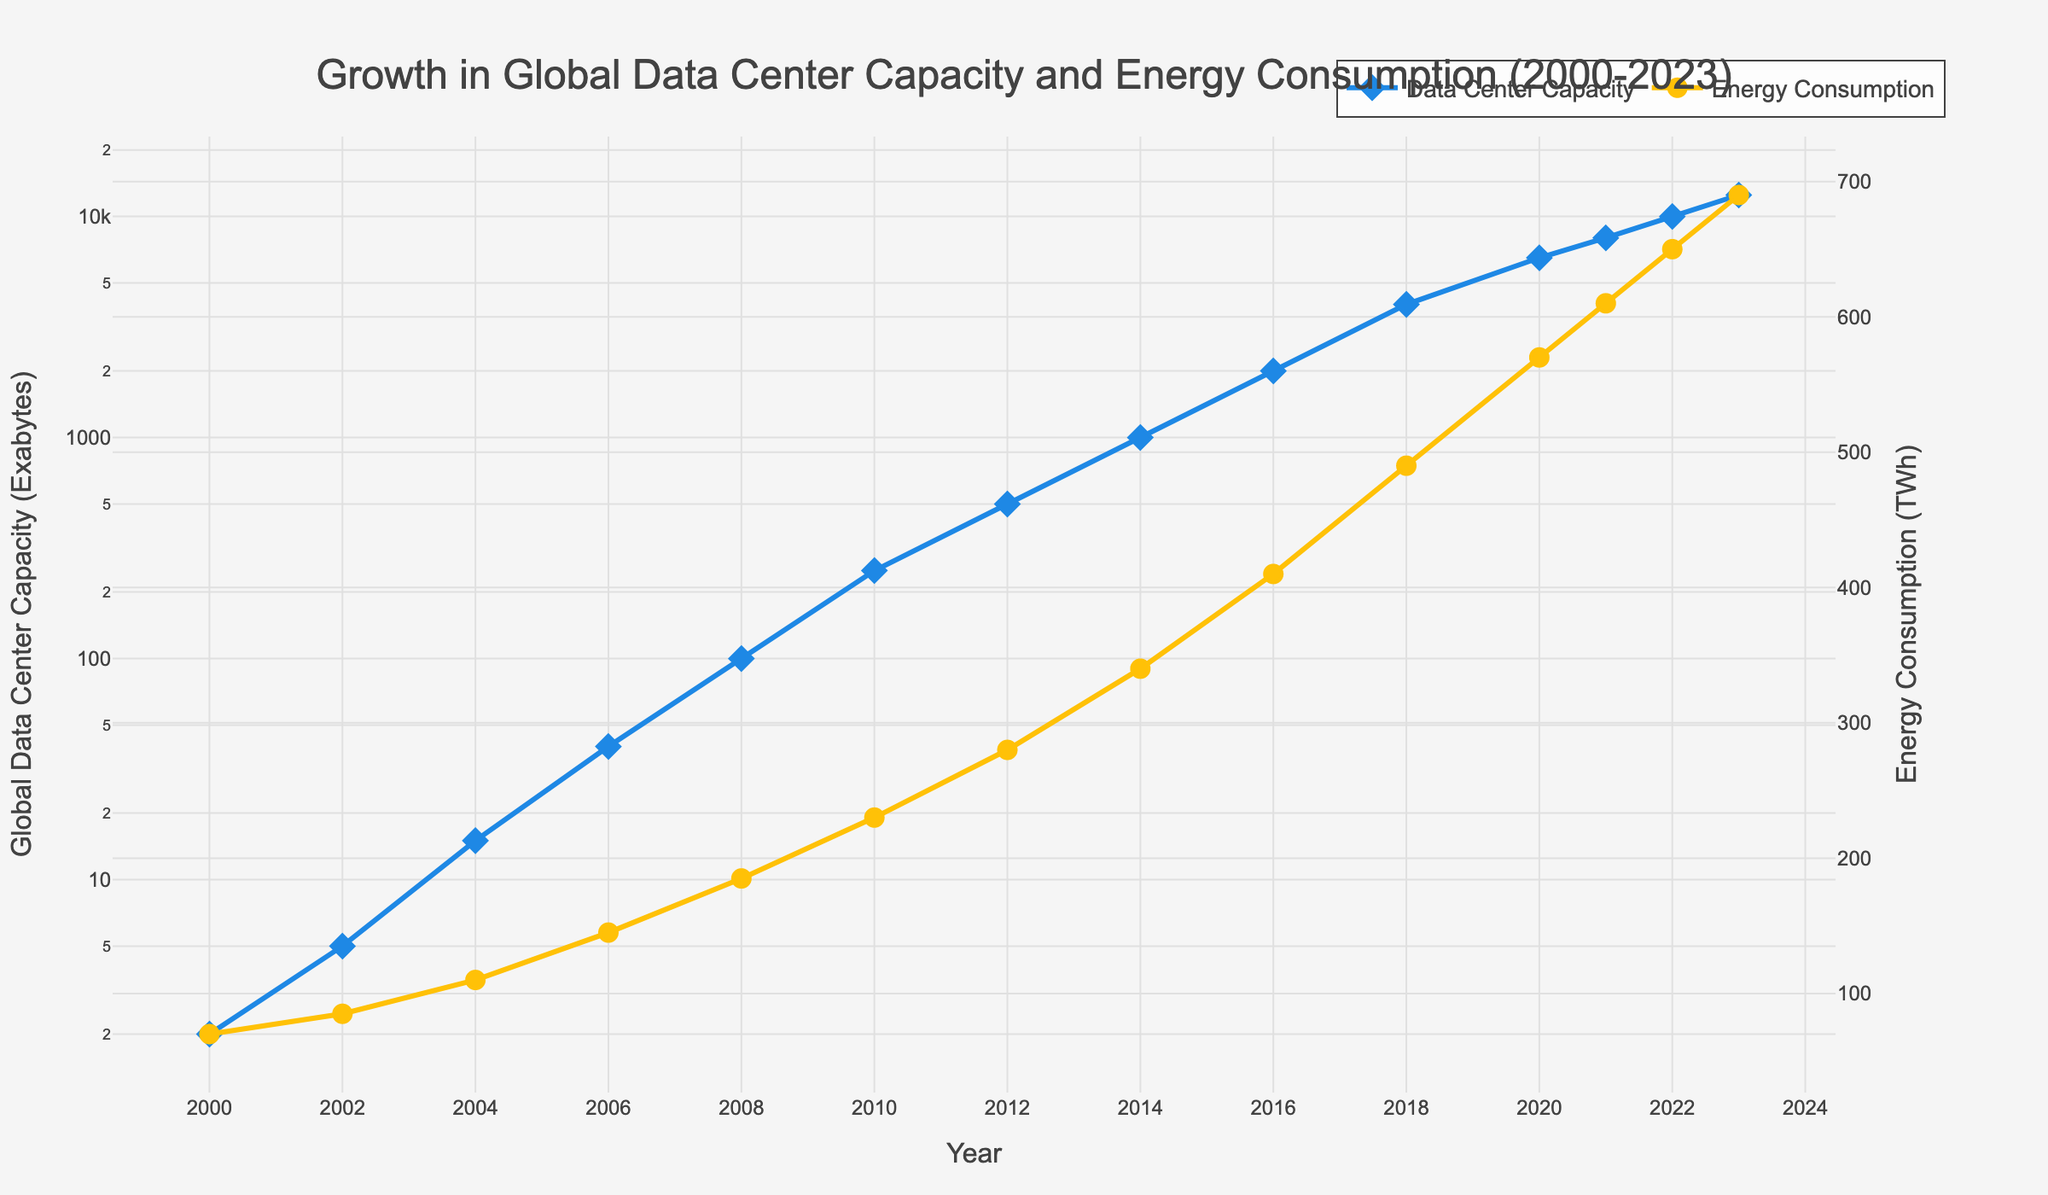What was the global data center capacity in 2010? Look at the data point for the year 2010 on the blue line, which represents global data center capacity. The value is 250 Exabytes.
Answer: 250 Exabytes How much did energy consumption increase from 2000 to 2004? Look at the data points for the years 2000 and 2004 on the yellow line, which represents energy consumption. Subtract the 2000 value (70 TWh) from the 2004 value (110 TWh): 110 - 70 = 40 TWh.
Answer: 40 TWh Between which years did the global data center capacity see the highest increase in absolute terms? To find the year-to-year differences, compare all consecutive data points on the blue line. The highest increase is from 2018 (4000 Exabytes) to 2020 (6500 Exabytes), which is 2500 Exabytes.
Answer: 2018 to 2020 Compare the energy consumption in 2018 with that in 2023. Which year had higher energy consumption, and by how much? Look at the data points for 2018 (490 TWh) and 2023 (690 TWh) on the yellow line. Subtract the 2018 value from the 2023 value: 690 - 490 = 200 TWh. 2023 had higher energy consumption by 200 TWh.
Answer: 2023, 200 TWh more What is the average global data center capacity between 2000 and 2008 inclusive? Add the capacity values for 2000 (2 Exabytes), 2002 (5 Exabytes), 2004 (15 Exabytes), 2006 (40 Exabytes), and 2008 (100 Exabytes). Sum = 2 + 5 + 15 + 40 + 100 = 162 Exabytes. Then divide by the number of years: 162 / 5 = 32.4 Exabytes.
Answer: 32.4 Exabytes Which year marked the first time global data center capacity exceeded 1000 Exabytes? Look at the blue line and find the first year where the value is above 1000 Exabytes. This occurs in 2014 (1000 Exabytes). Therefore, the year after, 2016 (2000 Exabytes), marks this milestone.
Answer: 2016 Is there any year where energy consumption increased while global data center capacity remained constant? Both lines are continuously increasing across the entire period (2000-2023). There are no years where global data center capacity is constant while energy consumption increases.
Answer: No Calculate the percent increase in energy consumption from 2010 to 2014. Energy consumption in 2010 is 230 TWh, and in 2014 is 340 TWh. The percent increase is ((340 - 230) / 230) * 100 = 47.83%.
Answer: 47.83% 